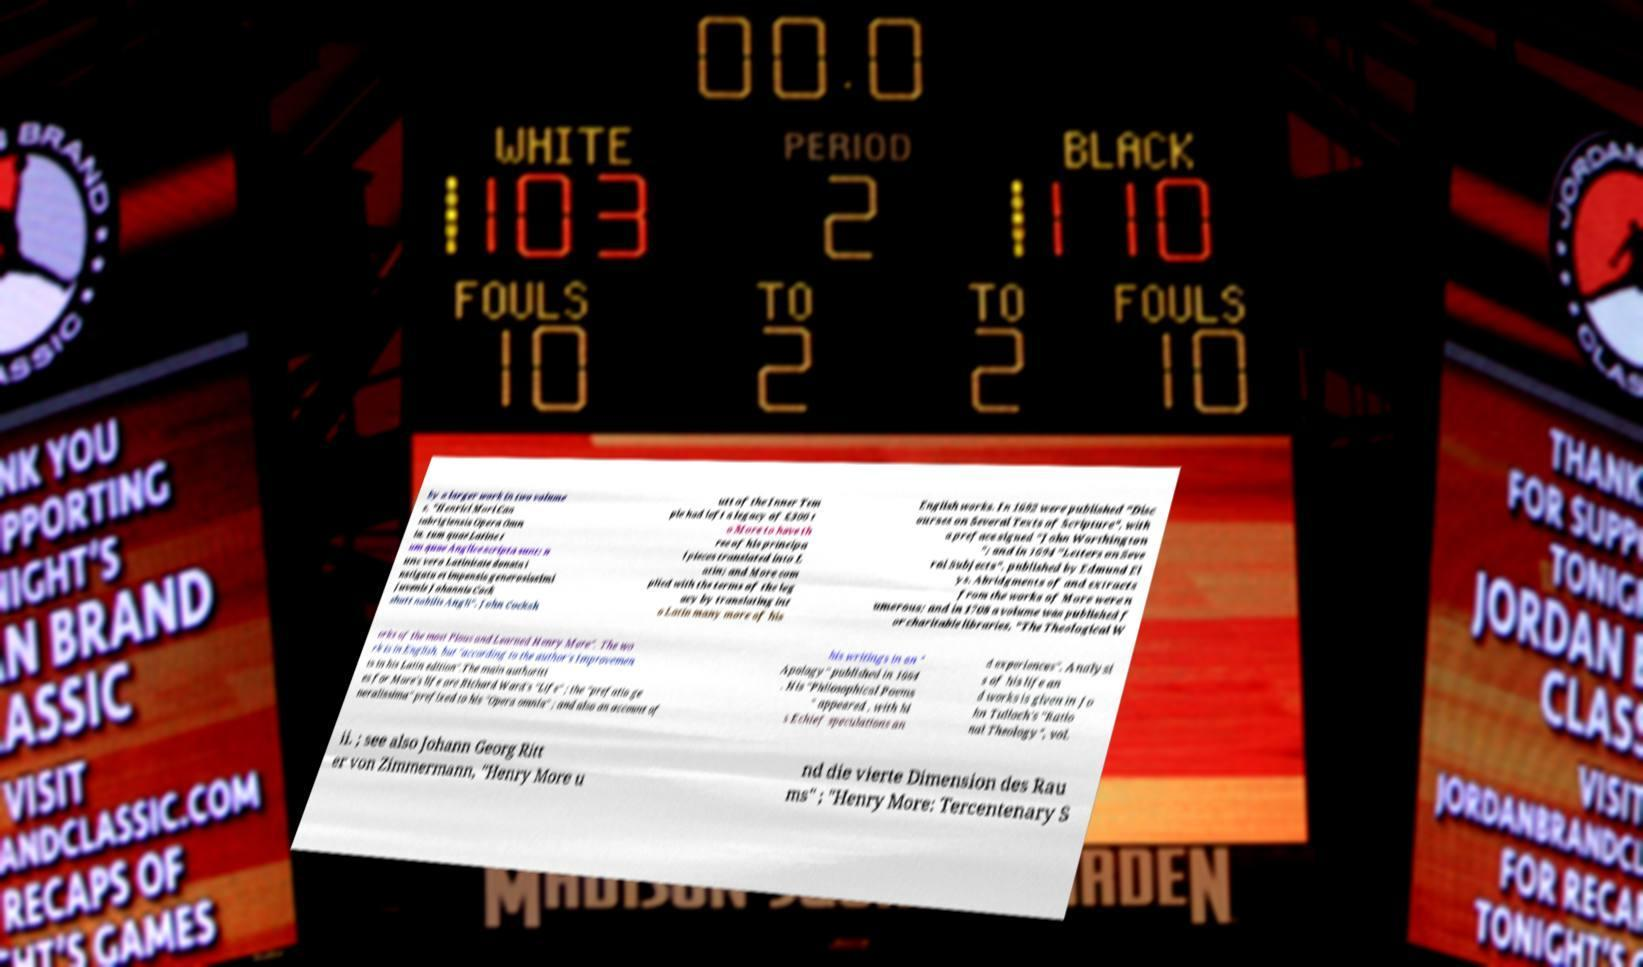For documentation purposes, I need the text within this image transcribed. Could you provide that? by a larger work in two volume s, "Henrici Mori Can tabrigiensis Opera Omn ia, tum quae Latine t um quae Anglice scripta sunt; n unc vero Latinitate donata i nstigatu et impensis generosissimi juvenis Johannis Cock shutt nobilis Angli". John Cocksh utt of the Inner Tem ple had left a legacy of £300 t o More to have th ree of his principa l pieces translated into L atin; and More com plied with the terms of the leg acy by translating int o Latin many more of his English works. In 1692 were published "Disc ourses on Several Texts of Scripture", with a preface signed "John Worthington "; and in 1694 "Letters on Seve ral Subjects", published by Edmund El ys. Abridgments of and extracts from the works of More were n umerous; and in 1708 a volume was published f or charitable libraries, "The Theological W orks of the most Pious and Learned Henry More". The wo rk is in English, but "according to the author's Improvemen ts in his Latin edition".The main authoriti es for More's life are Richard Ward's "Life" ; the "prefatio ge neralissima" prefixed to his "Opera omnia" ; and also an account of his writings in an " Apology" published in 1664 . His "Philosophical Poems " appeared , with hi s Echief speculations an d experiences". Analysi s of his life an d works is given in Jo hn Tulloch's "Ratio nal Theology", vol. ii. ; see also Johann Georg Ritt er von Zimmermann, "Henry More u nd die vierte Dimension des Rau ms" ; "Henry More: Tercentenary S 